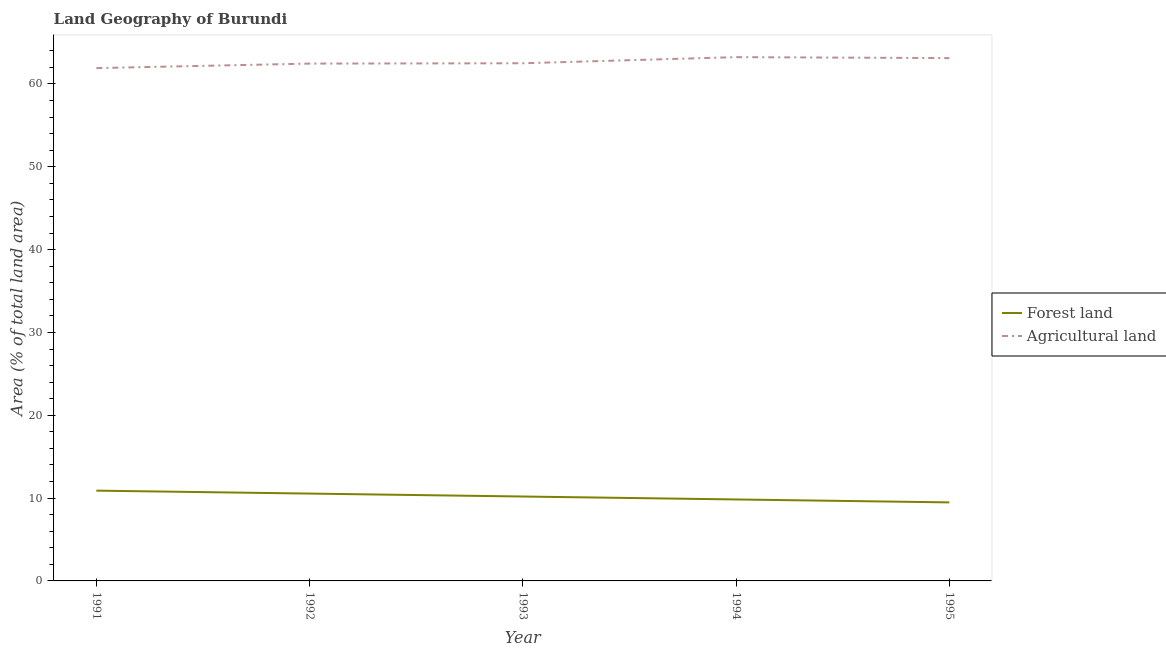How many different coloured lines are there?
Keep it short and to the point. 2. Does the line corresponding to percentage of land area under agriculture intersect with the line corresponding to percentage of land area under forests?
Provide a short and direct response. No. What is the percentage of land area under forests in 1994?
Your answer should be compact. 9.84. Across all years, what is the maximum percentage of land area under forests?
Your answer should be compact. 10.9. Across all years, what is the minimum percentage of land area under forests?
Keep it short and to the point. 9.48. In which year was the percentage of land area under forests maximum?
Give a very brief answer. 1991. What is the total percentage of land area under forests in the graph?
Ensure brevity in your answer.  50.95. What is the difference between the percentage of land area under agriculture in 1993 and that in 1994?
Your answer should be compact. -0.74. What is the difference between the percentage of land area under agriculture in 1992 and the percentage of land area under forests in 1994?
Provide a succinct answer. 52.62. What is the average percentage of land area under agriculture per year?
Your answer should be very brief. 62.65. In the year 1992, what is the difference between the percentage of land area under agriculture and percentage of land area under forests?
Ensure brevity in your answer.  51.92. In how many years, is the percentage of land area under forests greater than 2 %?
Ensure brevity in your answer.  5. What is the ratio of the percentage of land area under forests in 1994 to that in 1995?
Your answer should be compact. 1.04. Is the percentage of land area under forests in 1991 less than that in 1995?
Your response must be concise. No. What is the difference between the highest and the second highest percentage of land area under agriculture?
Ensure brevity in your answer.  0.12. What is the difference between the highest and the lowest percentage of land area under agriculture?
Offer a very short reply. 1.32. In how many years, is the percentage of land area under agriculture greater than the average percentage of land area under agriculture taken over all years?
Your answer should be very brief. 2. Does the percentage of land area under forests monotonically increase over the years?
Offer a very short reply. No. Is the percentage of land area under forests strictly greater than the percentage of land area under agriculture over the years?
Provide a short and direct response. No. Is the percentage of land area under agriculture strictly less than the percentage of land area under forests over the years?
Your answer should be compact. No. How many lines are there?
Give a very brief answer. 2. How many years are there in the graph?
Offer a very short reply. 5. Does the graph contain any zero values?
Offer a terse response. No. Does the graph contain grids?
Your response must be concise. No. Where does the legend appear in the graph?
Offer a very short reply. Center right. How many legend labels are there?
Offer a terse response. 2. What is the title of the graph?
Make the answer very short. Land Geography of Burundi. Does "Research and Development" appear as one of the legend labels in the graph?
Offer a terse response. No. What is the label or title of the Y-axis?
Your answer should be very brief. Area (% of total land area). What is the Area (% of total land area) of Forest land in 1991?
Offer a very short reply. 10.9. What is the Area (% of total land area) of Agricultural land in 1991?
Provide a short and direct response. 61.92. What is the Area (% of total land area) in Forest land in 1992?
Your answer should be compact. 10.55. What is the Area (% of total land area) of Agricultural land in 1992?
Offer a very short reply. 62.46. What is the Area (% of total land area) in Forest land in 1993?
Ensure brevity in your answer.  10.19. What is the Area (% of total land area) in Agricultural land in 1993?
Your response must be concise. 62.5. What is the Area (% of total land area) of Forest land in 1994?
Your answer should be compact. 9.84. What is the Area (% of total land area) of Agricultural land in 1994?
Make the answer very short. 63.24. What is the Area (% of total land area) in Forest land in 1995?
Your answer should be compact. 9.48. What is the Area (% of total land area) in Agricultural land in 1995?
Your response must be concise. 63.12. Across all years, what is the maximum Area (% of total land area) of Forest land?
Provide a short and direct response. 10.9. Across all years, what is the maximum Area (% of total land area) of Agricultural land?
Your answer should be compact. 63.24. Across all years, what is the minimum Area (% of total land area) in Forest land?
Provide a succinct answer. 9.48. Across all years, what is the minimum Area (% of total land area) of Agricultural land?
Your answer should be very brief. 61.92. What is the total Area (% of total land area) of Forest land in the graph?
Your answer should be compact. 50.95. What is the total Area (% of total land area) of Agricultural land in the graph?
Offer a very short reply. 313.24. What is the difference between the Area (% of total land area) of Forest land in 1991 and that in 1992?
Offer a terse response. 0.35. What is the difference between the Area (% of total land area) of Agricultural land in 1991 and that in 1992?
Your answer should be compact. -0.55. What is the difference between the Area (% of total land area) in Forest land in 1991 and that in 1993?
Make the answer very short. 0.71. What is the difference between the Area (% of total land area) in Agricultural land in 1991 and that in 1993?
Your answer should be compact. -0.58. What is the difference between the Area (% of total land area) of Forest land in 1991 and that in 1994?
Offer a very short reply. 1.06. What is the difference between the Area (% of total land area) of Agricultural land in 1991 and that in 1994?
Make the answer very short. -1.32. What is the difference between the Area (% of total land area) of Forest land in 1991 and that in 1995?
Make the answer very short. 1.42. What is the difference between the Area (% of total land area) in Agricultural land in 1991 and that in 1995?
Give a very brief answer. -1.21. What is the difference between the Area (% of total land area) of Forest land in 1992 and that in 1993?
Your response must be concise. 0.35. What is the difference between the Area (% of total land area) in Agricultural land in 1992 and that in 1993?
Provide a succinct answer. -0.04. What is the difference between the Area (% of total land area) of Forest land in 1992 and that in 1994?
Your response must be concise. 0.71. What is the difference between the Area (% of total land area) in Agricultural land in 1992 and that in 1994?
Give a very brief answer. -0.78. What is the difference between the Area (% of total land area) of Forest land in 1992 and that in 1995?
Make the answer very short. 1.06. What is the difference between the Area (% of total land area) of Agricultural land in 1992 and that in 1995?
Your response must be concise. -0.66. What is the difference between the Area (% of total land area) in Forest land in 1993 and that in 1994?
Provide a short and direct response. 0.35. What is the difference between the Area (% of total land area) in Agricultural land in 1993 and that in 1994?
Make the answer very short. -0.74. What is the difference between the Area (% of total land area) of Forest land in 1993 and that in 1995?
Offer a very short reply. 0.71. What is the difference between the Area (% of total land area) in Agricultural land in 1993 and that in 1995?
Your answer should be very brief. -0.62. What is the difference between the Area (% of total land area) of Forest land in 1994 and that in 1995?
Make the answer very short. 0.35. What is the difference between the Area (% of total land area) in Agricultural land in 1994 and that in 1995?
Make the answer very short. 0.12. What is the difference between the Area (% of total land area) in Forest land in 1991 and the Area (% of total land area) in Agricultural land in 1992?
Make the answer very short. -51.56. What is the difference between the Area (% of total land area) in Forest land in 1991 and the Area (% of total land area) in Agricultural land in 1993?
Provide a succinct answer. -51.6. What is the difference between the Area (% of total land area) in Forest land in 1991 and the Area (% of total land area) in Agricultural land in 1994?
Ensure brevity in your answer.  -52.34. What is the difference between the Area (% of total land area) in Forest land in 1991 and the Area (% of total land area) in Agricultural land in 1995?
Provide a short and direct response. -52.22. What is the difference between the Area (% of total land area) in Forest land in 1992 and the Area (% of total land area) in Agricultural land in 1993?
Ensure brevity in your answer.  -51.95. What is the difference between the Area (% of total land area) of Forest land in 1992 and the Area (% of total land area) of Agricultural land in 1994?
Provide a succinct answer. -52.69. What is the difference between the Area (% of total land area) of Forest land in 1992 and the Area (% of total land area) of Agricultural land in 1995?
Your response must be concise. -52.58. What is the difference between the Area (% of total land area) in Forest land in 1993 and the Area (% of total land area) in Agricultural land in 1994?
Your answer should be very brief. -53.05. What is the difference between the Area (% of total land area) of Forest land in 1993 and the Area (% of total land area) of Agricultural land in 1995?
Give a very brief answer. -52.93. What is the difference between the Area (% of total land area) in Forest land in 1994 and the Area (% of total land area) in Agricultural land in 1995?
Make the answer very short. -53.29. What is the average Area (% of total land area) of Forest land per year?
Make the answer very short. 10.19. What is the average Area (% of total land area) in Agricultural land per year?
Give a very brief answer. 62.65. In the year 1991, what is the difference between the Area (% of total land area) of Forest land and Area (% of total land area) of Agricultural land?
Provide a short and direct response. -51.02. In the year 1992, what is the difference between the Area (% of total land area) in Forest land and Area (% of total land area) in Agricultural land?
Your answer should be very brief. -51.92. In the year 1993, what is the difference between the Area (% of total land area) of Forest land and Area (% of total land area) of Agricultural land?
Keep it short and to the point. -52.31. In the year 1994, what is the difference between the Area (% of total land area) of Forest land and Area (% of total land area) of Agricultural land?
Give a very brief answer. -53.4. In the year 1995, what is the difference between the Area (% of total land area) in Forest land and Area (% of total land area) in Agricultural land?
Your response must be concise. -53.64. What is the ratio of the Area (% of total land area) in Forest land in 1991 to that in 1992?
Provide a short and direct response. 1.03. What is the ratio of the Area (% of total land area) of Forest land in 1991 to that in 1993?
Give a very brief answer. 1.07. What is the ratio of the Area (% of total land area) in Forest land in 1991 to that in 1994?
Ensure brevity in your answer.  1.11. What is the ratio of the Area (% of total land area) in Agricultural land in 1991 to that in 1994?
Offer a terse response. 0.98. What is the ratio of the Area (% of total land area) of Forest land in 1991 to that in 1995?
Your answer should be compact. 1.15. What is the ratio of the Area (% of total land area) of Agricultural land in 1991 to that in 1995?
Offer a very short reply. 0.98. What is the ratio of the Area (% of total land area) in Forest land in 1992 to that in 1993?
Offer a terse response. 1.03. What is the ratio of the Area (% of total land area) of Forest land in 1992 to that in 1994?
Keep it short and to the point. 1.07. What is the ratio of the Area (% of total land area) in Forest land in 1992 to that in 1995?
Provide a succinct answer. 1.11. What is the ratio of the Area (% of total land area) in Agricultural land in 1992 to that in 1995?
Your response must be concise. 0.99. What is the ratio of the Area (% of total land area) in Forest land in 1993 to that in 1994?
Keep it short and to the point. 1.04. What is the ratio of the Area (% of total land area) in Agricultural land in 1993 to that in 1994?
Give a very brief answer. 0.99. What is the ratio of the Area (% of total land area) of Forest land in 1993 to that in 1995?
Your answer should be compact. 1.07. What is the ratio of the Area (% of total land area) in Forest land in 1994 to that in 1995?
Your response must be concise. 1.04. What is the ratio of the Area (% of total land area) in Agricultural land in 1994 to that in 1995?
Ensure brevity in your answer.  1. What is the difference between the highest and the second highest Area (% of total land area) in Forest land?
Ensure brevity in your answer.  0.35. What is the difference between the highest and the second highest Area (% of total land area) of Agricultural land?
Make the answer very short. 0.12. What is the difference between the highest and the lowest Area (% of total land area) in Forest land?
Your response must be concise. 1.42. What is the difference between the highest and the lowest Area (% of total land area) in Agricultural land?
Keep it short and to the point. 1.32. 